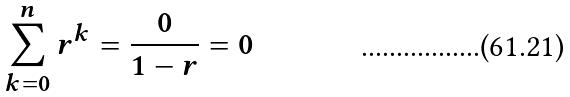<formula> <loc_0><loc_0><loc_500><loc_500>\sum _ { k = 0 } ^ { n } r ^ { k } = \frac { 0 } { 1 - r } = 0</formula> 